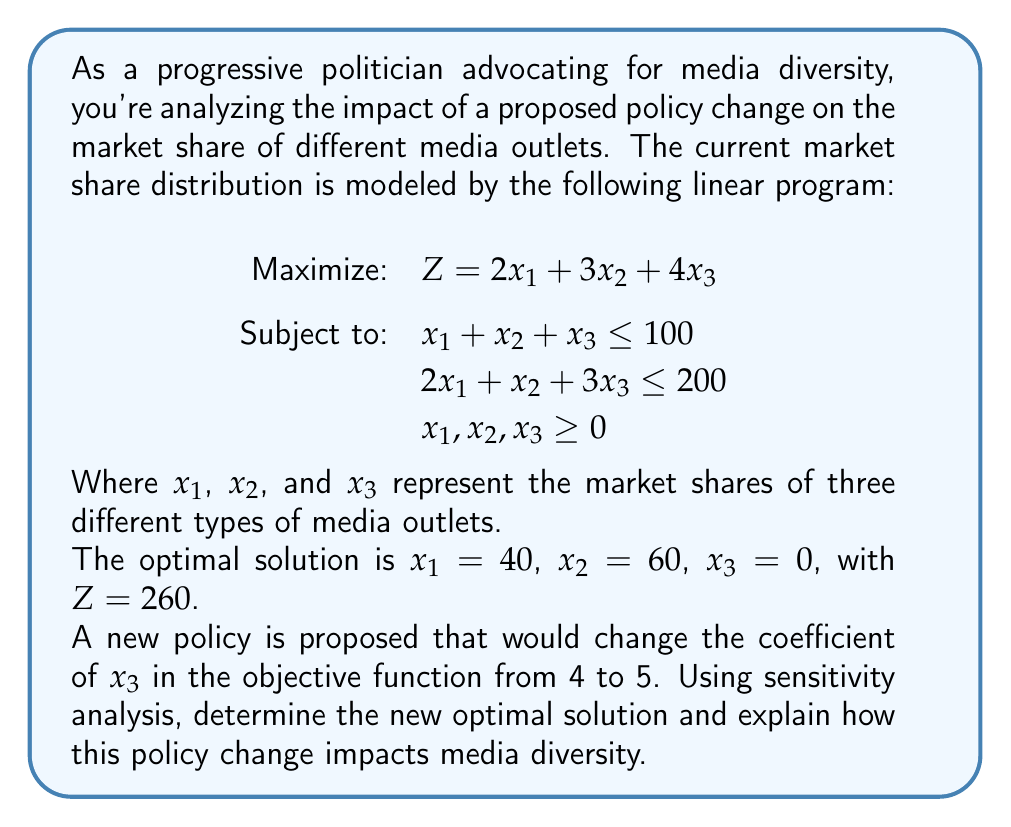Show me your answer to this math problem. To solve this problem, we'll use sensitivity analysis to determine how the change in the objective function coefficient affects the optimal solution.

Step 1: Examine the current optimal solution
The current optimal solution is $x_1 = 40$, $x_2 = 60$, $x_3 = 0$, with $Z = 260$.

Step 2: Determine the reduced costs
The reduced cost for $x_3$ in the current solution is:
$c_3 - z_3 = 4 - (2 \cdot 0 + 3 \cdot 1 + 4 \cdot \frac{1}{3}) = -\frac{1}{3}$

Step 3: Analyze the impact of the coefficient change
The proposed change increases the coefficient of $x_3$ from 4 to 5.
New reduced cost for $x_3$: $5 - (2 \cdot 0 + 3 \cdot 1 + 4 \cdot \frac{1}{3}) = \frac{2}{3}$

Since the new reduced cost is positive, $x_3$ will enter the basis in the new optimal solution.

Step 4: Determine the new optimal solution
We need to solve the updated linear program:

Maximize: $Z = 2x_1 + 3x_2 + 5x_3$
Subject to:
$x_1 + x_2 + x_3 \leq 100$
$2x_1 + x_2 + 3x_3 \leq 200$
$x_1, x_2, x_3 \geq 0$

Solving this using the simplex method (omitted for brevity), we get:
$x_1 = 0$, $x_2 = 70$, $x_3 = 30$, with $Z = 360$

Step 5: Analyze the impact on media diversity
The policy change has led to a significant shift in the market share distribution:
- $x_1$ (Type 1 media) decreased from 40 to 0
- $x_2$ (Type 2 media) increased from 60 to 70
- $x_3$ (Type 3 media) increased from 0 to 30

This change has increased the presence of Type 3 media, which was previously absent from the market. It has also slightly increased the share of Type 2 media while eliminating Type 1 media. Overall, the market now includes two types of media instead of just one, indicating an increase in media diversity.
Answer: New optimal solution: $x_1 = 0$, $x_2 = 70$, $x_3 = 30$. The policy change increases media diversity by introducing Type 3 media and reducing market concentration. 